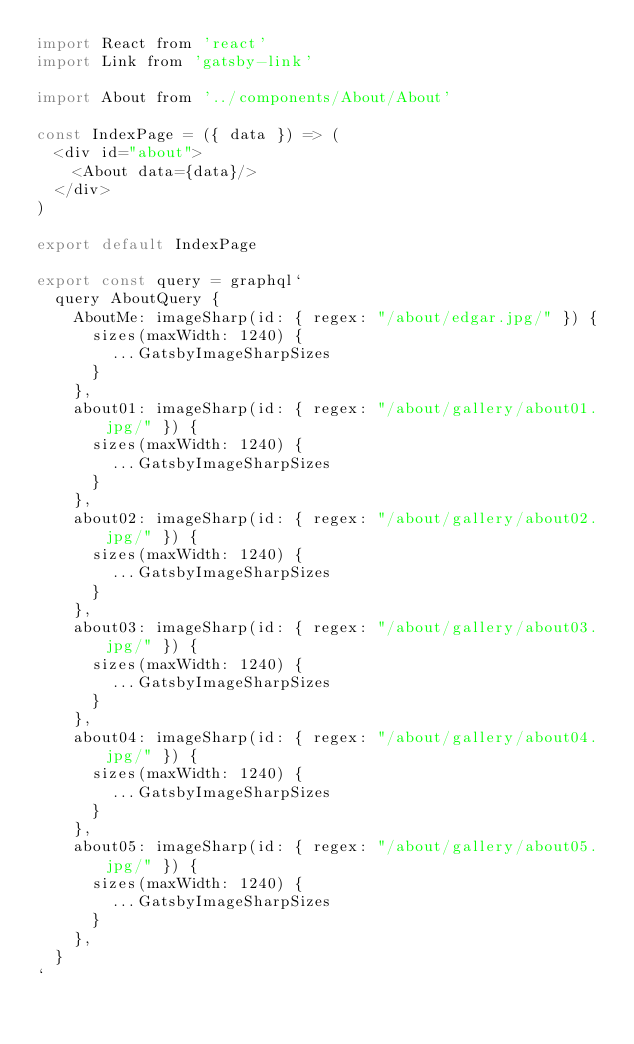<code> <loc_0><loc_0><loc_500><loc_500><_JavaScript_>import React from 'react'
import Link from 'gatsby-link'

import About from '../components/About/About'

const IndexPage = ({ data }) => (
  <div id="about">
    <About data={data}/>
  </div>
)

export default IndexPage

export const query = graphql`
  query AboutQuery {
    AboutMe: imageSharp(id: { regex: "/about/edgar.jpg/" }) {
      sizes(maxWidth: 1240) {
        ...GatsbyImageSharpSizes
      }
    },
    about01: imageSharp(id: { regex: "/about/gallery/about01.jpg/" }) {
      sizes(maxWidth: 1240) {
        ...GatsbyImageSharpSizes
      }
    },
    about02: imageSharp(id: { regex: "/about/gallery/about02.jpg/" }) {
      sizes(maxWidth: 1240) {
        ...GatsbyImageSharpSizes
      }
    },
    about03: imageSharp(id: { regex: "/about/gallery/about03.jpg/" }) {
      sizes(maxWidth: 1240) {
        ...GatsbyImageSharpSizes
      }
    },
    about04: imageSharp(id: { regex: "/about/gallery/about04.jpg/" }) {
      sizes(maxWidth: 1240) {
        ...GatsbyImageSharpSizes
      }
    },
    about05: imageSharp(id: { regex: "/about/gallery/about05.jpg/" }) {
      sizes(maxWidth: 1240) {
        ...GatsbyImageSharpSizes
      }
    },
  }
`
</code> 